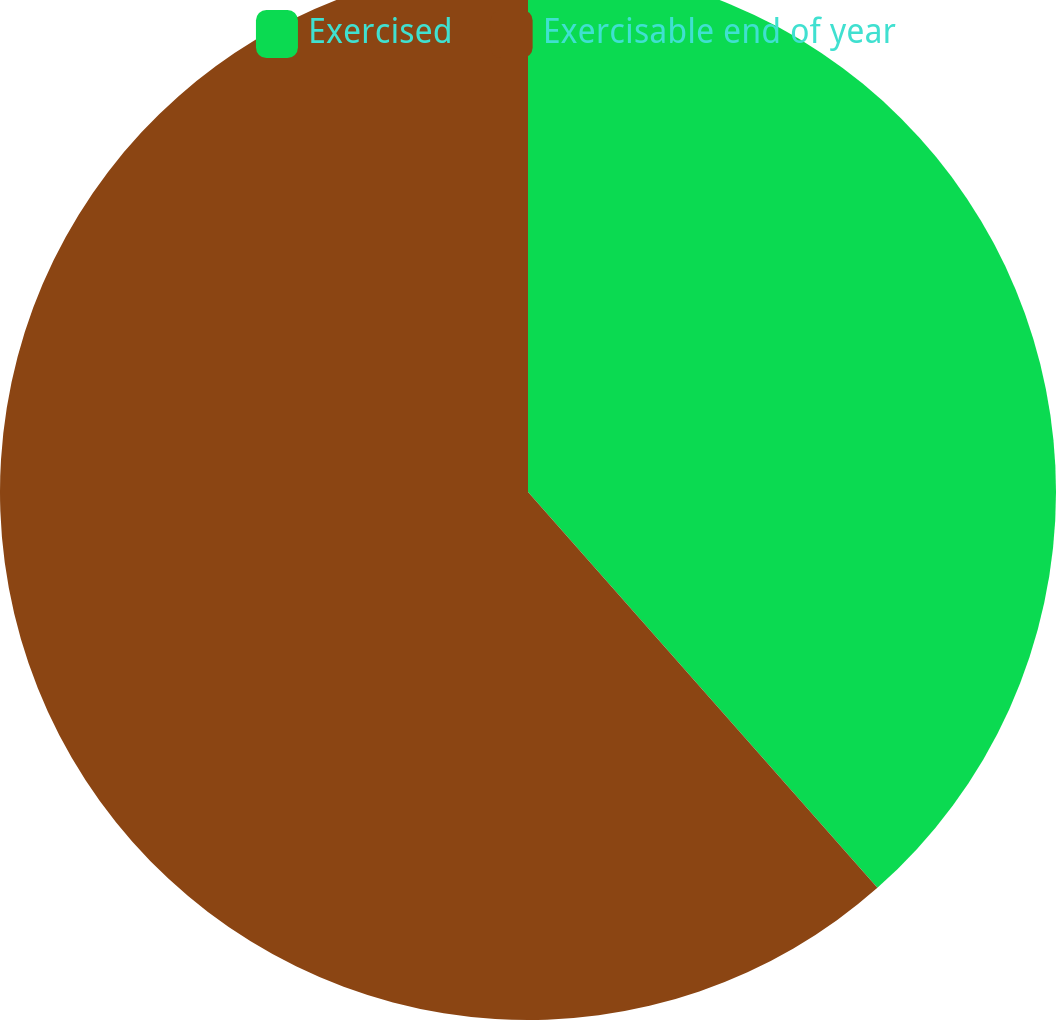<chart> <loc_0><loc_0><loc_500><loc_500><pie_chart><fcel>Exercised<fcel>Exercisable end of year<nl><fcel>38.49%<fcel>61.51%<nl></chart> 